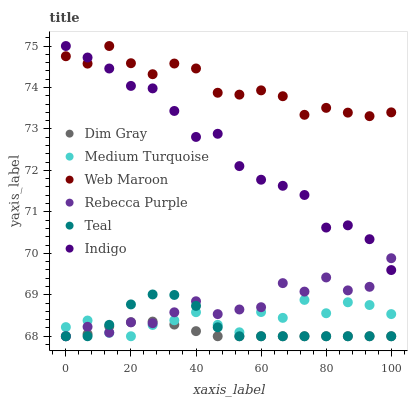Does Dim Gray have the minimum area under the curve?
Answer yes or no. Yes. Does Web Maroon have the maximum area under the curve?
Answer yes or no. Yes. Does Indigo have the minimum area under the curve?
Answer yes or no. No. Does Indigo have the maximum area under the curve?
Answer yes or no. No. Is Dim Gray the smoothest?
Answer yes or no. Yes. Is Rebecca Purple the roughest?
Answer yes or no. Yes. Is Indigo the smoothest?
Answer yes or no. No. Is Indigo the roughest?
Answer yes or no. No. Does Dim Gray have the lowest value?
Answer yes or no. Yes. Does Indigo have the lowest value?
Answer yes or no. No. Does Web Maroon have the highest value?
Answer yes or no. Yes. Does Medium Turquoise have the highest value?
Answer yes or no. No. Is Rebecca Purple less than Web Maroon?
Answer yes or no. Yes. Is Indigo greater than Medium Turquoise?
Answer yes or no. Yes. Does Rebecca Purple intersect Medium Turquoise?
Answer yes or no. Yes. Is Rebecca Purple less than Medium Turquoise?
Answer yes or no. No. Is Rebecca Purple greater than Medium Turquoise?
Answer yes or no. No. Does Rebecca Purple intersect Web Maroon?
Answer yes or no. No. 